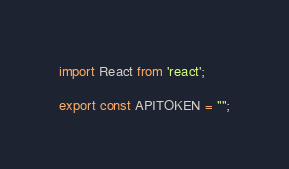Convert code to text. <code><loc_0><loc_0><loc_500><loc_500><_JavaScript_>import React from 'react';

export const APITOKEN = "";
</code> 